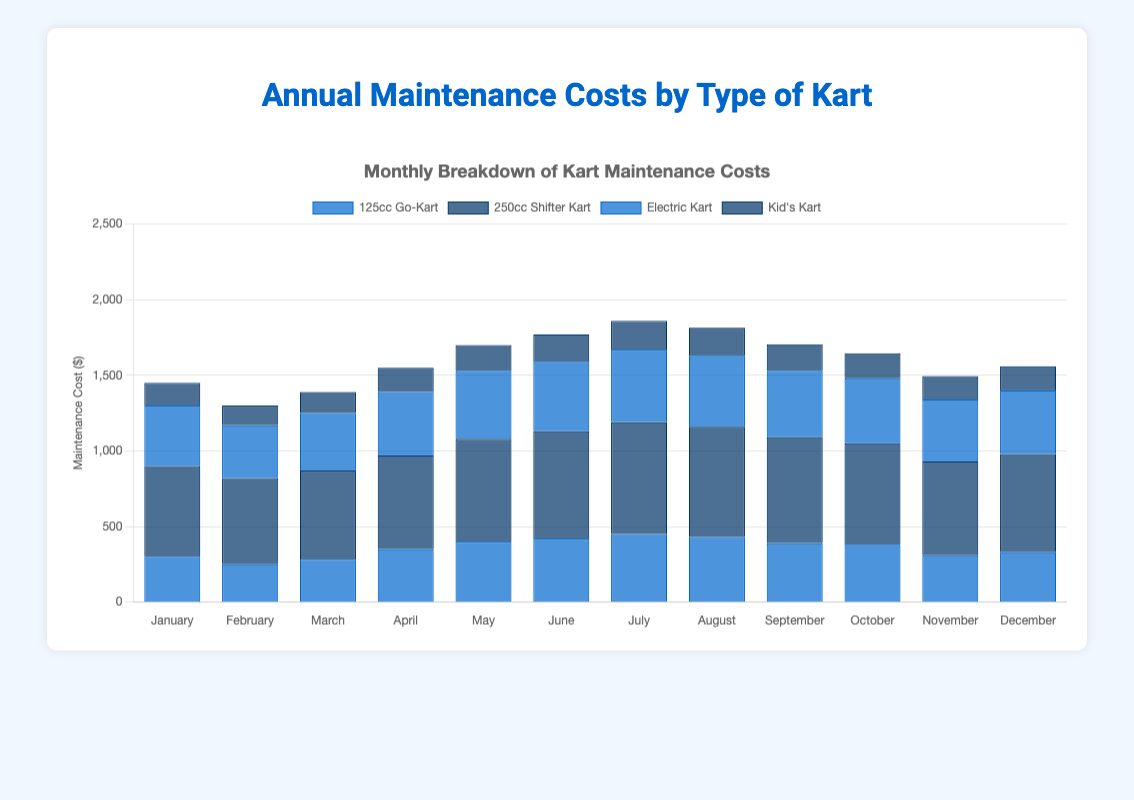Which type of kart has the highest maintenance cost in July? In the figure, look for the kart type with the tallest bar in the month of July. The 250cc Shifter Kart has the tallest bar in July.
Answer: 250cc Shifter Kart Which month had the lowest maintenance cost for the Kid's Kart? To find the month with the lowest maintenance cost for the Kid's Kart, look for the shortest bar in the Kid's Kart series. February has the shortest bar.
Answer: February What is the total annual maintenance cost for the 125cc Go-Kart? Sum the monthly maintenance costs for the 125cc Go-Kart. 300 + 250 + 280 + 350 + 400 + 420 + 450 + 430 + 390 + 380 + 310 + 330 = 4290.
Answer: 4290 Which kart type has the most stable (least variable) maintenance costs throughout the year? Examine each kart type and see which set of bars is the most consistent in height. The Kid's Kart bars are the most uniform.
Answer: Kid's Kart In which month did the Electric Kart's maintenance cost peak? Find the highest bar in the Electric Kart series. The highest bar occurs in the month of July.
Answer: July Which kart type had a higher maintenance cost in September, 125cc Go-Kart or Electric Kart? Compare the heights of the September bars for 125cc Go-Kart and Electric Kart. The Electric Kart's September bar is taller.
Answer: Electric Kart What is the average maintenance cost for the 250cc Shifter Kart in the first quarter (January to March)? Calculate the average by summing January, February, and March costs and dividing by 3. (600 + 570 + 590) / 3 = 1760 / 3 = 586.67.
Answer: 586.67 Which month shows a crossover in the maintenance costs of 125cc Go-Kart and 250cc Shifter Kart where the former exceeds the latter? Find the month where the 125cc Go-Kart bar is above the 250cc Shifter Kart bar. In May, the 125cc Go-Kart cost (400) is below the 250cc Shifter Kart (680), so this does not happen in any month.
Answer: None What is the difference in maintenance costs between the Electric Kart and Kid's Kart in June? Subtract the Kid's Kart June cost from the Electric Kart June cost. 460 - 180 = 280.
Answer: 280 